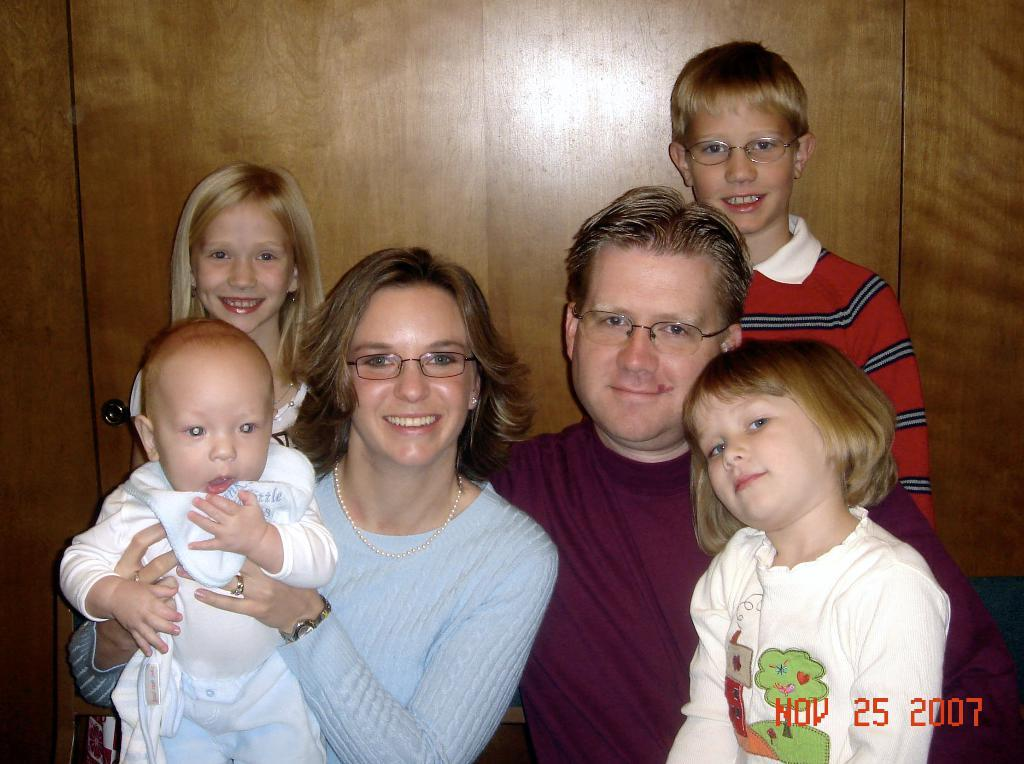What is happening in the center of the image? There is a group of persons sitting in the center of the image. What can be seen in the background of the image? There is a wall in the background of the image. What type of design can be seen on the wall in the image? There is no specific design mentioned in the provided facts, so we cannot determine the design on the wall from the image. 